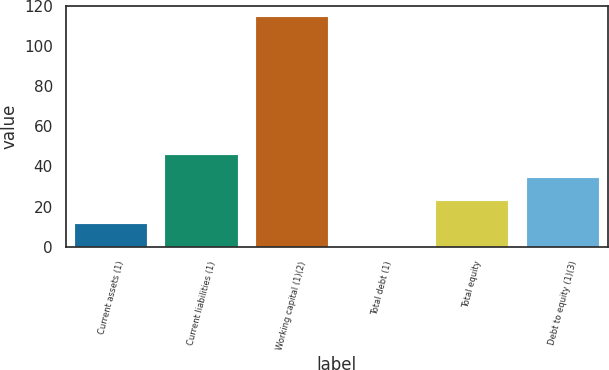Convert chart to OTSL. <chart><loc_0><loc_0><loc_500><loc_500><bar_chart><fcel>Current assets (1)<fcel>Current liabilities (1)<fcel>Working capital (1)(2)<fcel>Total debt (1)<fcel>Total equity<fcel>Debt to equity (1)(3)<nl><fcel>11.52<fcel>45.78<fcel>114.3<fcel>0.1<fcel>22.94<fcel>34.36<nl></chart> 